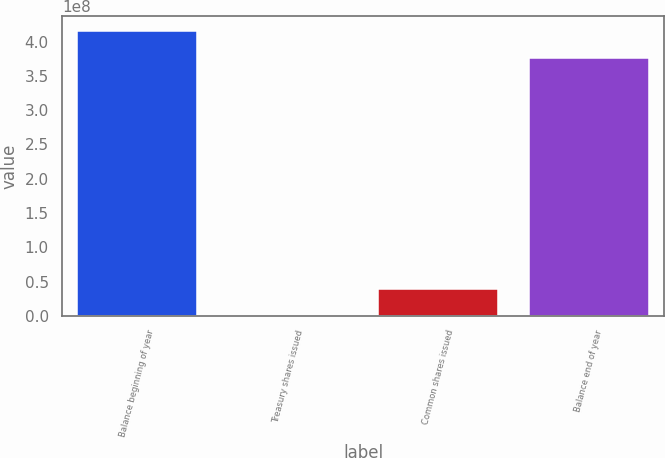Convert chart. <chart><loc_0><loc_0><loc_500><loc_500><bar_chart><fcel>Balance beginning of year<fcel>Treasury shares issued<fcel>Common shares issued<fcel>Balance end of year<nl><fcel>4.1608e+08<fcel>17454<fcel>3.9593e+07<fcel>3.76505e+08<nl></chart> 